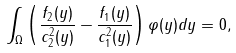<formula> <loc_0><loc_0><loc_500><loc_500>\int _ { \Omega } \left ( \frac { f _ { 2 } ( y ) } { c _ { 2 } ^ { 2 } ( y ) } - \frac { f _ { 1 } ( y ) } { c _ { 1 } ^ { 2 } ( y ) } \right ) \varphi ( y ) d y = 0 ,</formula> 